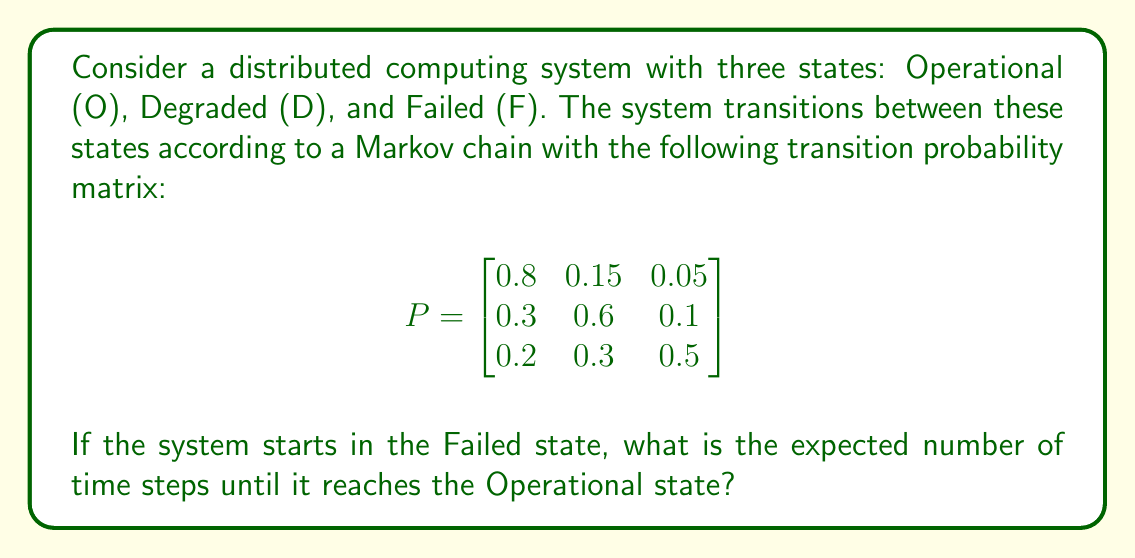Show me your answer to this math problem. To solve this problem, we'll use the concept of expected hitting time in Markov chains.

Step 1: Define the states
Let state 1 be Operational (O), state 2 be Degraded (D), and state 3 be Failed (F).

Step 2: Set up the system of equations
Let $m_i$ be the expected number of steps to reach state 1 (Operational) starting from state $i$. We want to find $m_3$.

The system of equations is:
$$m_1 = 0$$
$$m_2 = 1 + 0.3m_1 + 0.6m_2 + 0.1m_3$$
$$m_3 = 1 + 0.2m_1 + 0.3m_2 + 0.5m_3$$

Step 3: Simplify the equations
$$m_1 = 0$$
$$0.4m_2 = 1 + 0.1m_3$$
$$0.5m_3 = 1 + 0.3m_2$$

Step 4: Solve the system of equations
From the second equation:
$$m_2 = 2.5 + 0.25m_3$$

Substitute this into the third equation:
$$0.5m_3 = 1 + 0.3(2.5 + 0.25m_3)$$
$$0.5m_3 = 1 + 0.75 + 0.075m_3$$
$$0.425m_3 = 1.75$$
$$m_3 = \frac{1.75}{0.425} = \frac{35}{8.5} \approx 4.12$$

Step 5: Interpret the result
The expected number of time steps to reach the Operational state from the Failed state is approximately 4.12 time steps.
Answer: $\frac{35}{8.5}$ time steps 